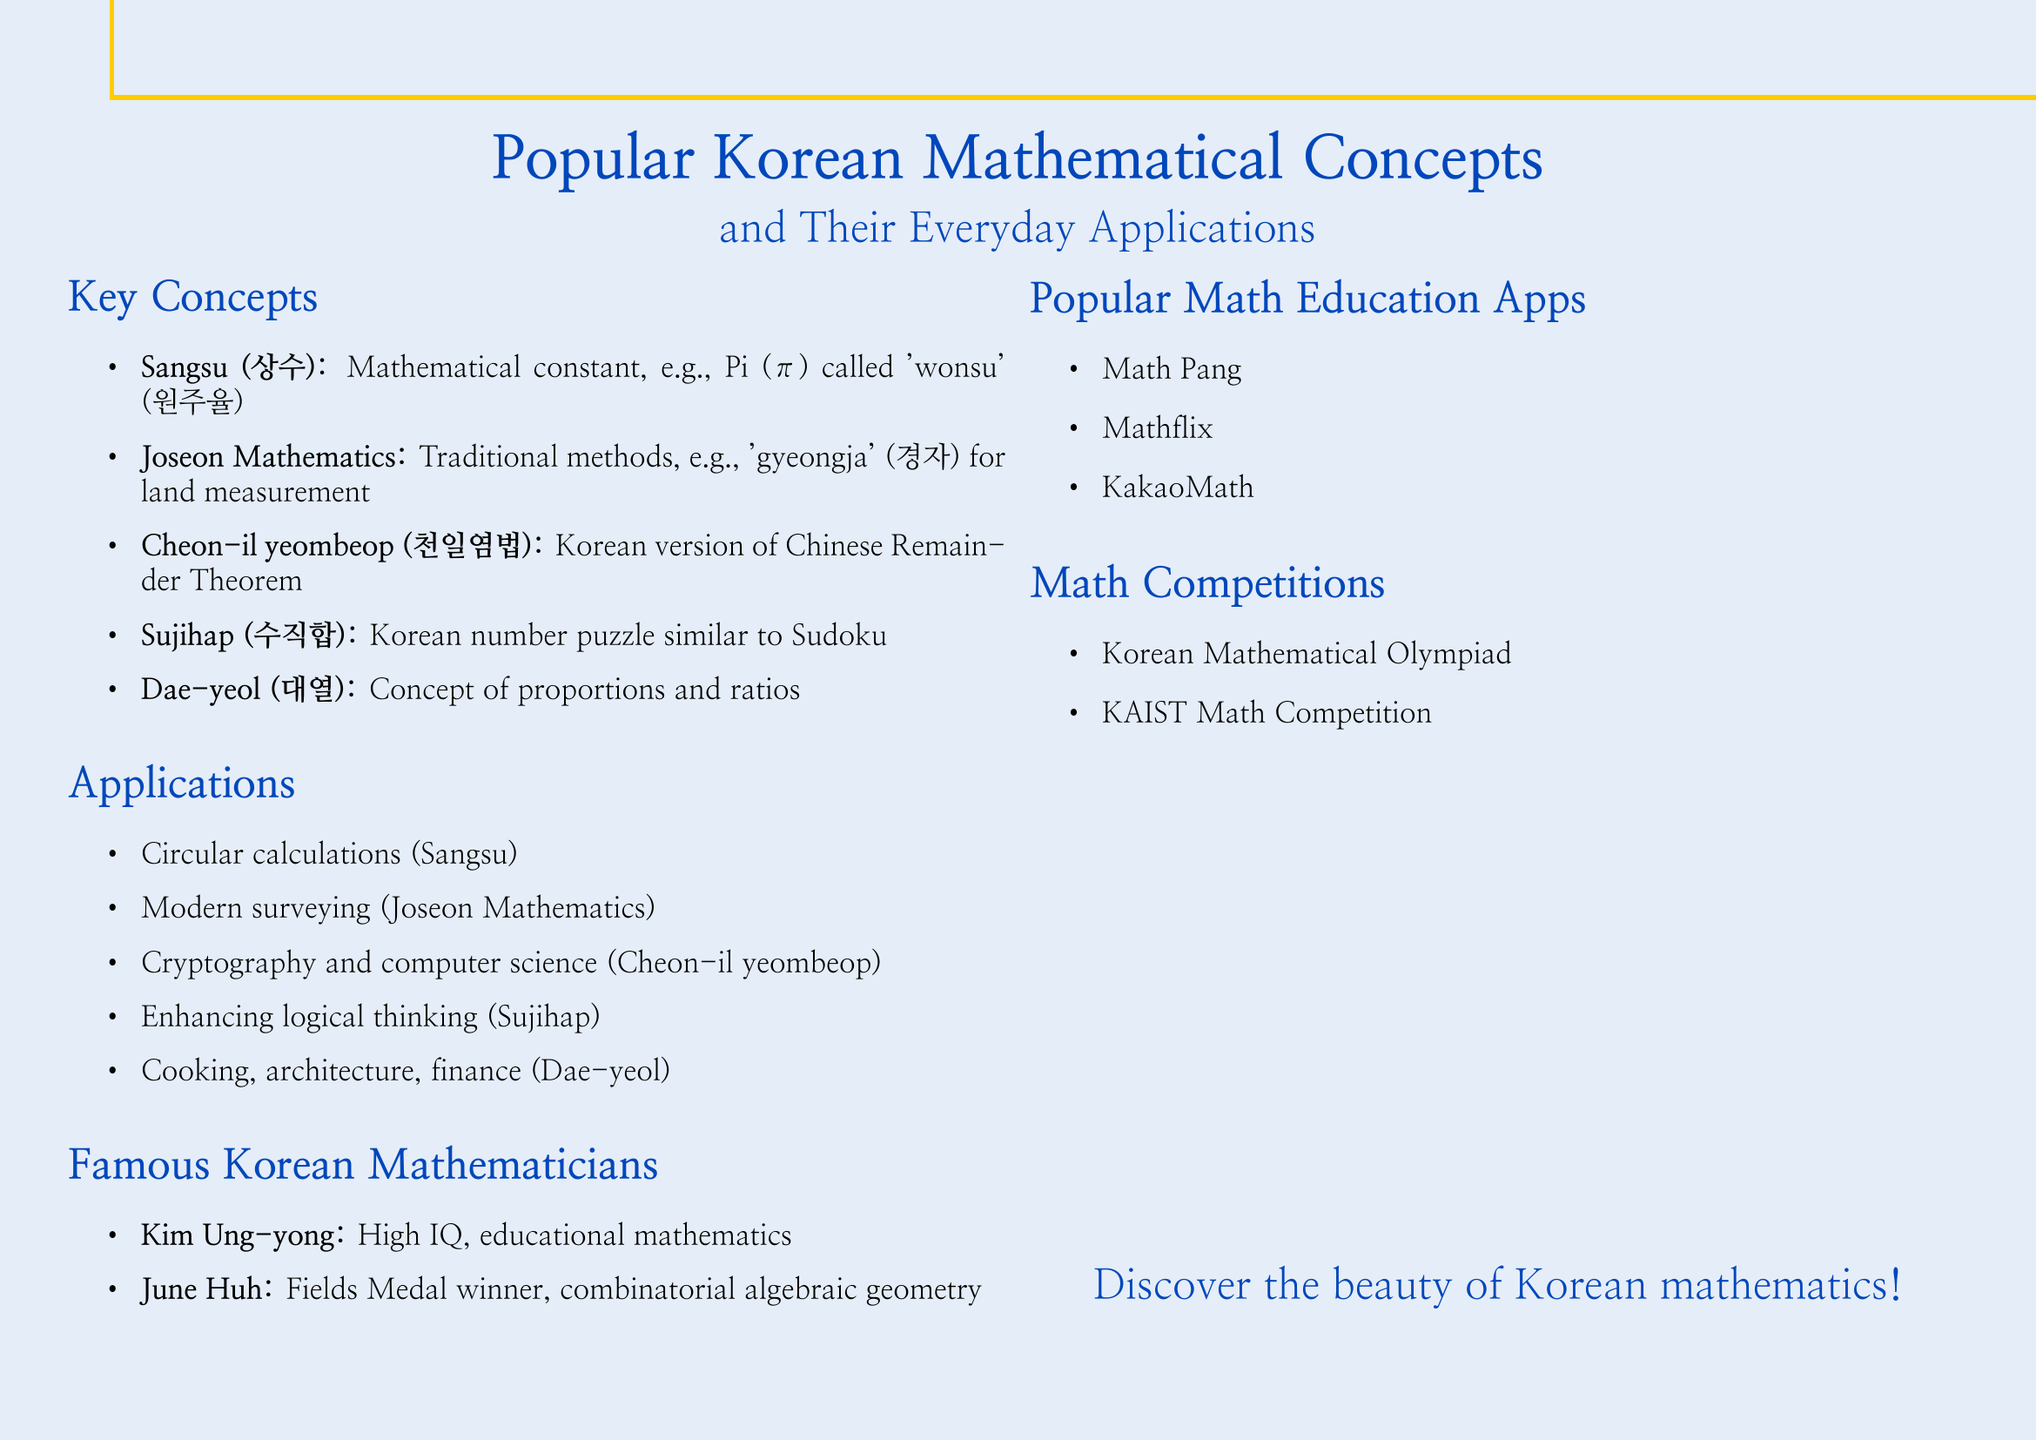What is the Korean term for mathematical constant? The document mentions "Sangsu" as the Korean term for a mathematical constant.
Answer: Sangsu (상수) What is the method used in Joseon Mathematics to measure land area? The document states the 'gyeongja' method is used for land measurement in Joseon Mathematics.
Answer: gyeongja (경자) Who is known for contributions to educational mathematics? The document lists Kim Ung-yong as known for his high IQ and contributions to educational mathematics.
Answer: Kim Ung-yong What is Sujihap similar to? Sujihap is referred to as a number puzzle that is similar to Sudoku.
Answer: Sudoku Which app is mentioned as a popular math education tool? The document lists "Math Pang" as one of the popular math education apps in Korea.
Answer: Math Pang What award did June Huh win? The document mentions June Huh as a winner of the Fields Medal for his work in mathematics.
Answer: Fields Medal In what fields is Dae-yeol commonly applied? According to the document, Dae-yeol is commonly used in cooking, architecture, and financial calculations.
Answer: Cooking, architecture, and financial calculations What traditional period does Joseon Mathematics refer to? The document states that Joseon Mathematics was developed during the Joseon Dynasty.
Answer: Joseon Dynasty How many popular math education apps are listed? The document lists three popular math education apps, indicating their number.
Answer: Three 